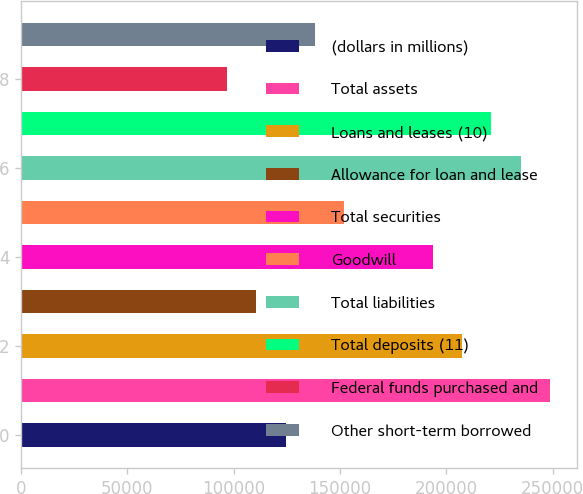Convert chart to OTSL. <chart><loc_0><loc_0><loc_500><loc_500><bar_chart><fcel>(dollars in millions)<fcel>Total assets<fcel>Loans and leases (10)<fcel>Allowance for loan and lease<fcel>Total securities<fcel>Goodwill<fcel>Total liabilities<fcel>Total deposits (11)<fcel>Federal funds purchased and<fcel>Other short-term borrowed<nl><fcel>124387<fcel>248773<fcel>207311<fcel>110567<fcel>193491<fcel>152029<fcel>234953<fcel>221132<fcel>96745.9<fcel>138208<nl></chart> 